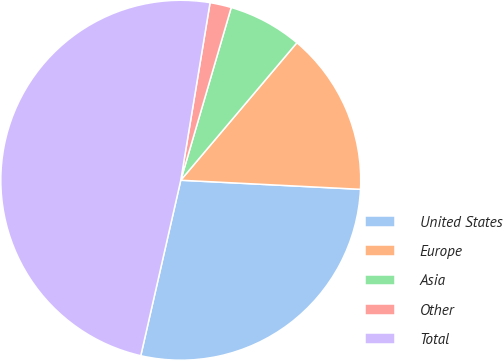Convert chart. <chart><loc_0><loc_0><loc_500><loc_500><pie_chart><fcel>United States<fcel>Europe<fcel>Asia<fcel>Other<fcel>Total<nl><fcel>27.76%<fcel>14.64%<fcel>6.64%<fcel>1.92%<fcel>49.03%<nl></chart> 